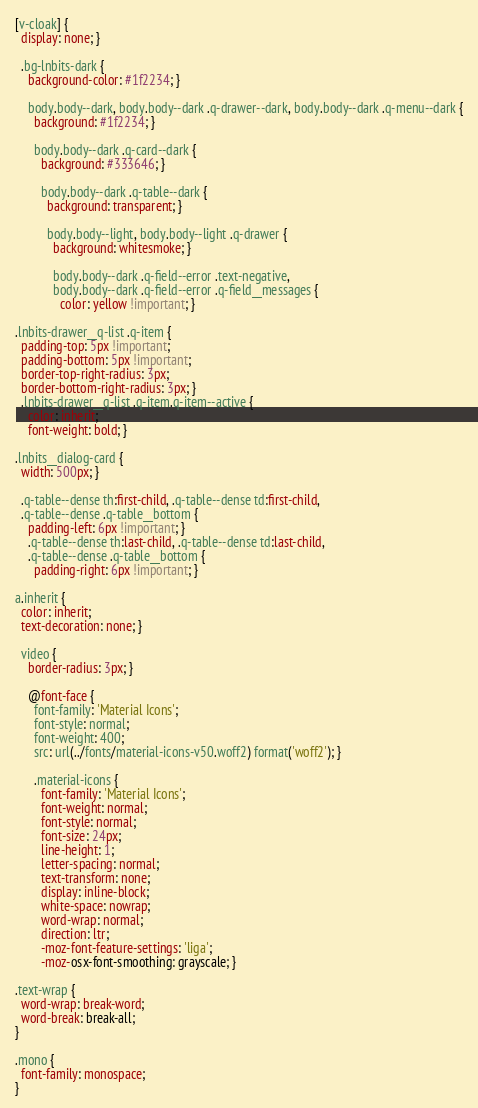Convert code to text. <code><loc_0><loc_0><loc_500><loc_500><_CSS_>[v-cloak] {
  display: none; }

  .bg-lnbits-dark {
    background-color: #1f2234; }

    body.body--dark, body.body--dark .q-drawer--dark, body.body--dark .q-menu--dark {
      background: #1f2234; }

      body.body--dark .q-card--dark {
        background: #333646; }

        body.body--dark .q-table--dark {
          background: transparent; }

          body.body--light, body.body--light .q-drawer {
            background: whitesmoke; }

            body.body--dark .q-field--error .text-negative,
            body.body--dark .q-field--error .q-field__messages {
              color: yellow !important; }

.lnbits-drawer__q-list .q-item {
  padding-top: 5px !important;
  padding-bottom: 5px !important;
  border-top-right-radius: 3px;
  border-bottom-right-radius: 3px; }
  .lnbits-drawer__q-list .q-item.q-item--active {
    color: inherit;
    font-weight: bold; }

.lnbits__dialog-card {
  width: 500px; }

  .q-table--dense th:first-child, .q-table--dense td:first-child,
  .q-table--dense .q-table__bottom {
    padding-left: 6px !important; }
    .q-table--dense th:last-child, .q-table--dense td:last-child,
    .q-table--dense .q-table__bottom {
      padding-right: 6px !important; }

a.inherit {
  color: inherit;
  text-decoration: none; }

  video {
    border-radius: 3px; }

    @font-face {
      font-family: 'Material Icons';
      font-style: normal;
      font-weight: 400;
      src: url(../fonts/material-icons-v50.woff2) format('woff2'); }

      .material-icons {
        font-family: 'Material Icons';
        font-weight: normal;
        font-style: normal;
        font-size: 24px;
        line-height: 1;
        letter-spacing: normal;
        text-transform: none;
        display: inline-block;
        white-space: nowrap;
        word-wrap: normal;
        direction: ltr;
        -moz-font-feature-settings: 'liga';
        -moz-osx-font-smoothing: grayscale; }

.text-wrap {
  word-wrap: break-word;
  word-break: break-all;
}

.mono {
  font-family: monospace;
}
</code> 